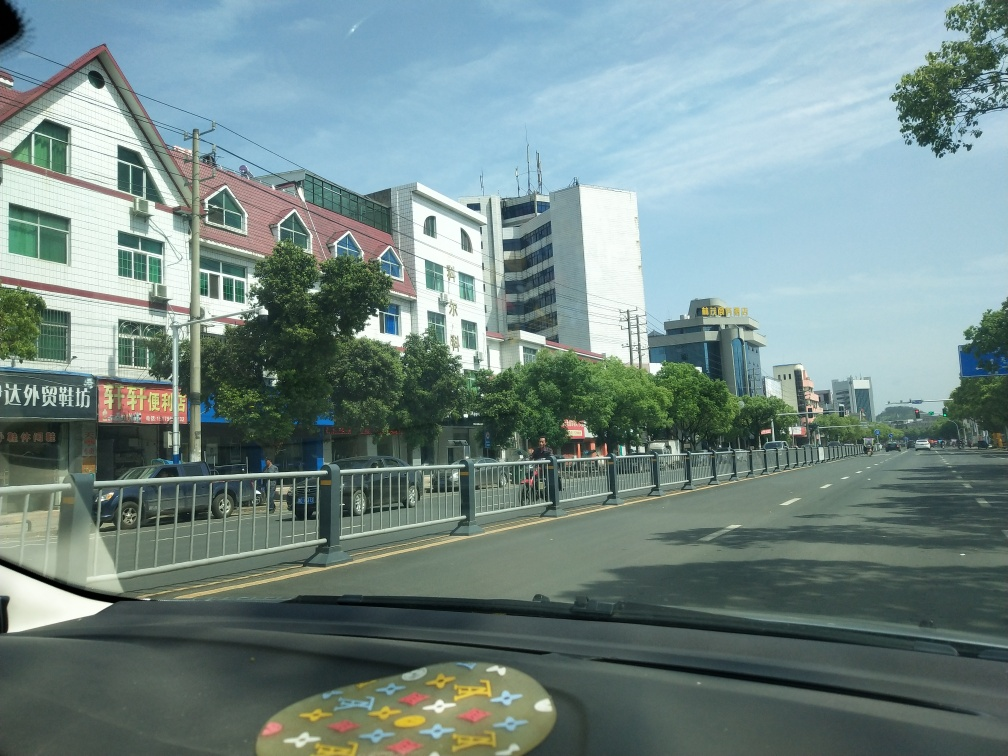What is the quality of this image? The image quality appears to be decent, when considering the factors such as clarity, exposure, and focus. The details of the streets, buildings, and vehicles are clear, the exposure is balanced with no areas of excessive brightness or darkness, and the focus is sharp across the entire scene. Although there is a minor obstruction at the bottom, likely from within the vehicle, it does not significantly detract from the overall quality of the image. 